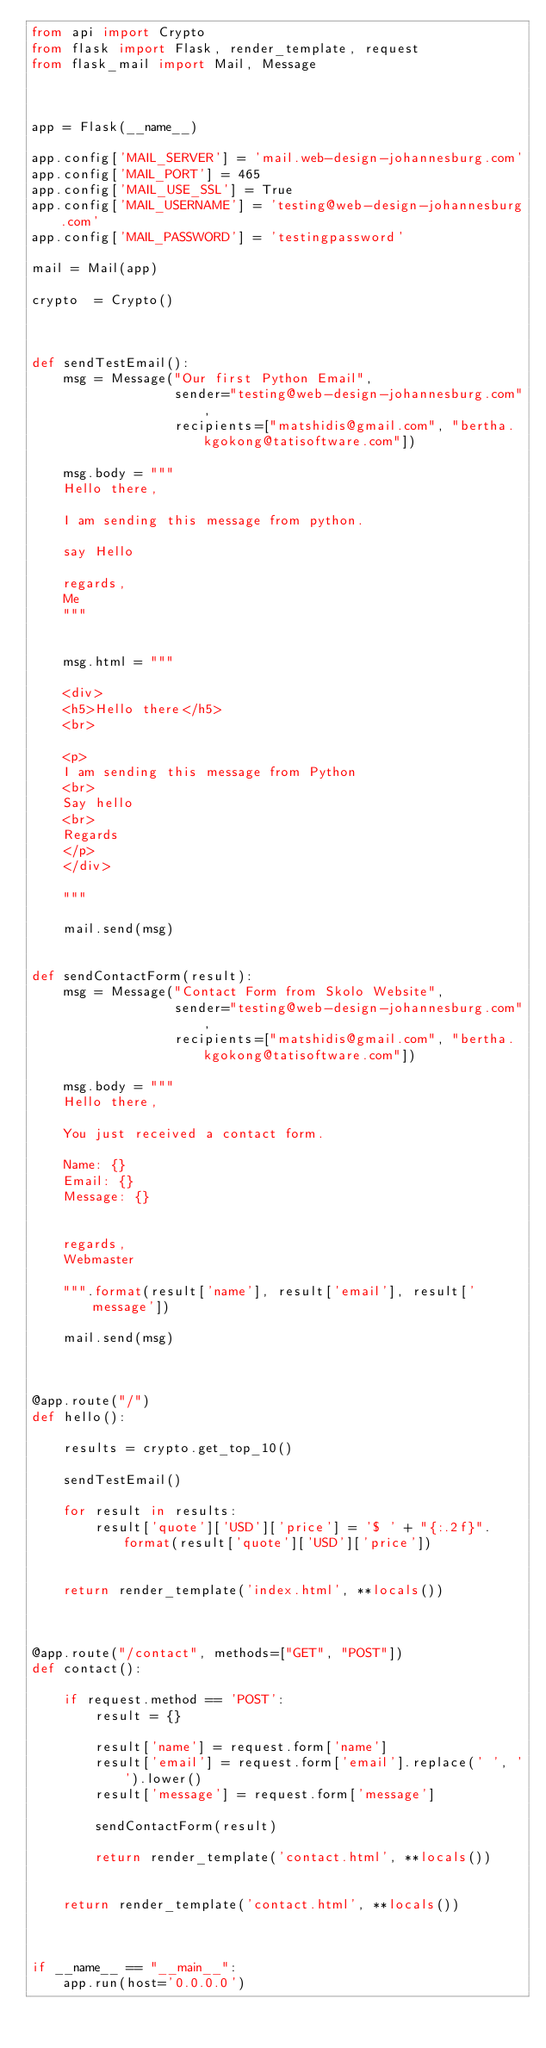<code> <loc_0><loc_0><loc_500><loc_500><_Python_>from api import Crypto
from flask import Flask, render_template, request
from flask_mail import Mail, Message



app = Flask(__name__)

app.config['MAIL_SERVER'] = 'mail.web-design-johannesburg.com'
app.config['MAIL_PORT'] = 465
app.config['MAIL_USE_SSL'] = True
app.config['MAIL_USERNAME'] = 'testing@web-design-johannesburg.com'
app.config['MAIL_PASSWORD'] = 'testingpassword'

mail = Mail(app)

crypto  = Crypto()



def sendTestEmail():
    msg = Message("Our first Python Email",
                  sender="testing@web-design-johannesburg.com",
                  recipients=["matshidis@gmail.com", "bertha.kgokong@tatisoftware.com"])

    msg.body = """ 
    Hello there,

    I am sending this message from python.

    say Hello

    regards,
    Me
    """


    msg.html = """

    <div>
    <h5>Hello there</h5>
    <br>

    <p>
    I am sending this message from Python 
    <br>
    Say hello 
    <br>
    Regards
    </p>
    </div>

    """

    mail.send(msg)


def sendContactForm(result):
    msg = Message("Contact Form from Skolo Website",
                  sender="testing@web-design-johannesburg.com",
                  recipients=["matshidis@gmail.com", "bertha.kgokong@tatisoftware.com"])

    msg.body = """
    Hello there,

    You just received a contact form.

    Name: {}
    Email: {}
    Message: {}


    regards,
    Webmaster

    """.format(result['name'], result['email'], result['message'])

    mail.send(msg)



@app.route("/")
def hello():

    results = crypto.get_top_10()

    sendTestEmail()

    for result in results:
        result['quote']['USD']['price'] = '$ ' + "{:.2f}".format(result['quote']['USD']['price'])


    return render_template('index.html', **locals())



@app.route("/contact", methods=["GET", "POST"])
def contact():

    if request.method == 'POST':
        result = {}
        
        result['name'] = request.form['name']
        result['email'] = request.form['email'].replace(' ', '').lower()
        result['message'] = request.form['message']

        sendContactForm(result)

        return render_template('contact.html', **locals())


    return render_template('contact.html', **locals())



if __name__ == "__main__":
    app.run(host='0.0.0.0')


</code> 